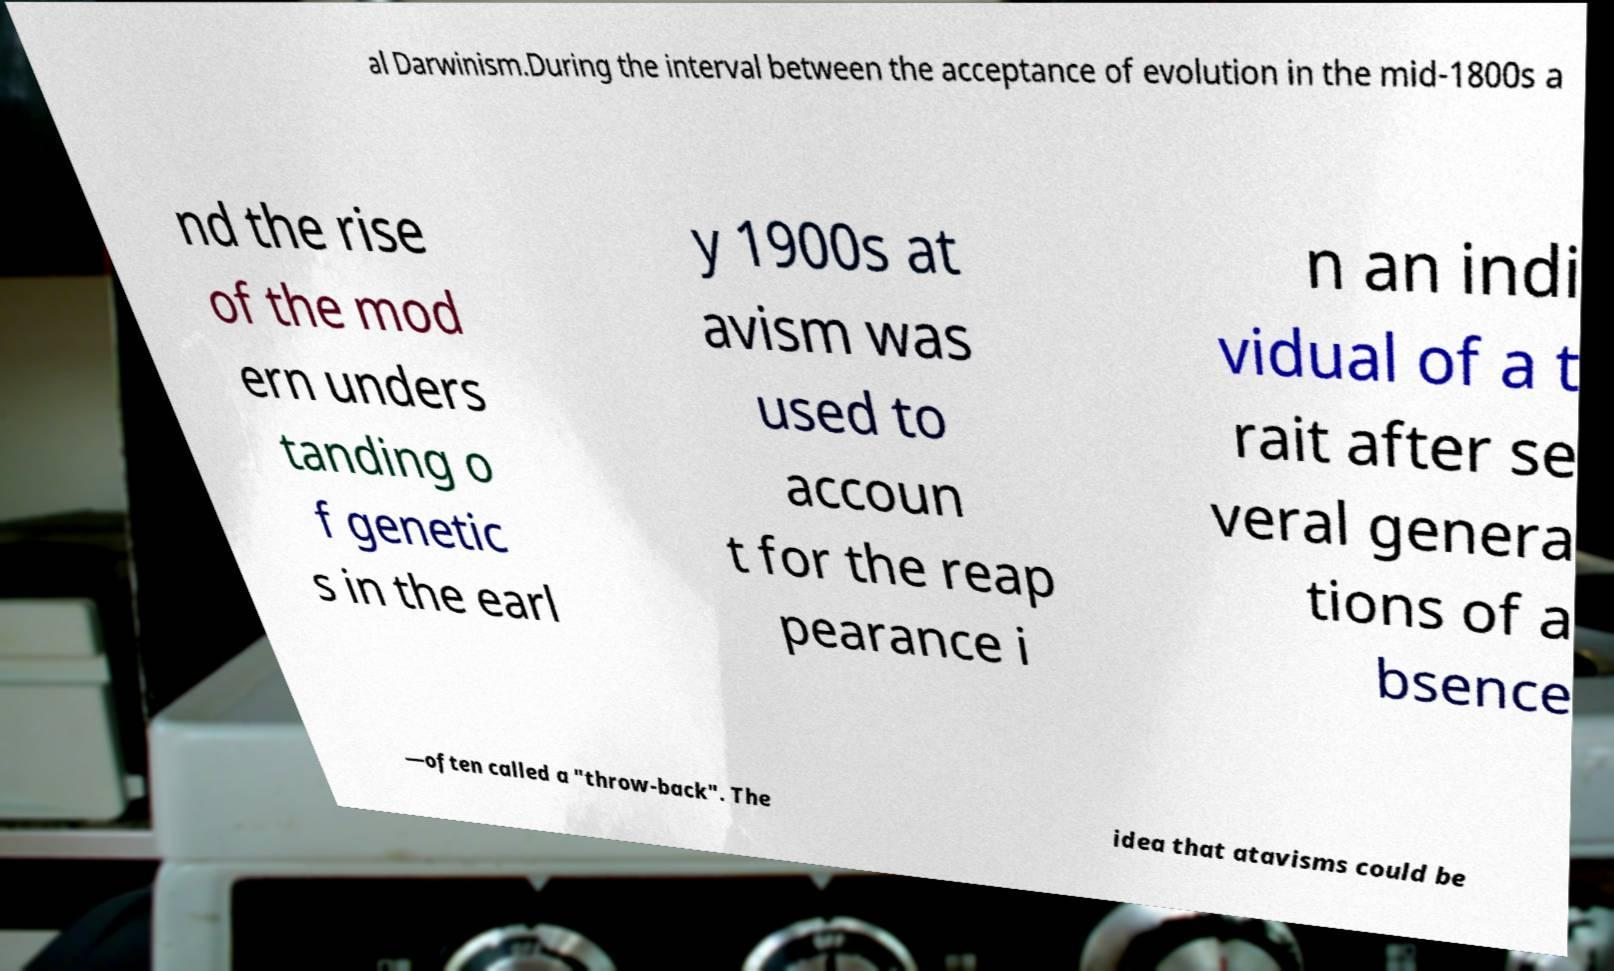Please read and relay the text visible in this image. What does it say? al Darwinism.During the interval between the acceptance of evolution in the mid-1800s a nd the rise of the mod ern unders tanding o f genetic s in the earl y 1900s at avism was used to accoun t for the reap pearance i n an indi vidual of a t rait after se veral genera tions of a bsence —often called a "throw-back". The idea that atavisms could be 